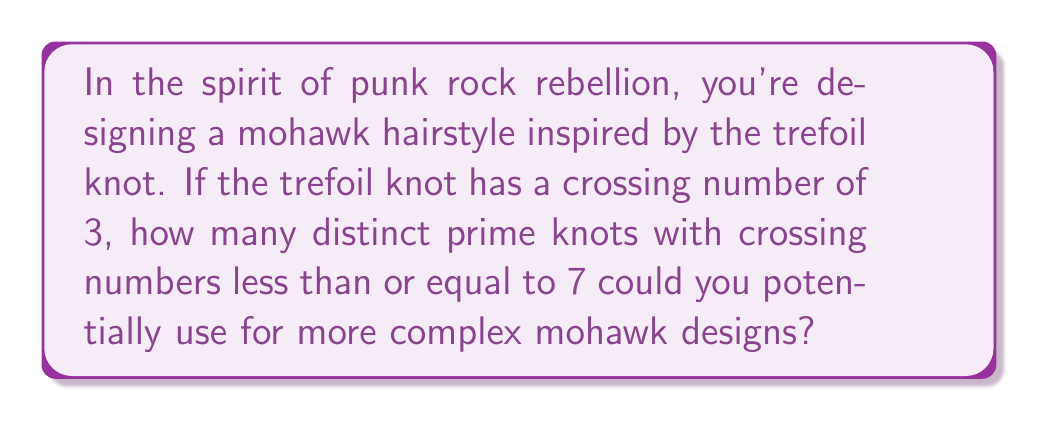Could you help me with this problem? To answer this question, we need to understand some basic concepts from knot theory and then count the number of prime knots with crossing numbers up to 7.

1. Knot theory basics:
   - A knot is a closed curve in three-dimensional space that doesn't intersect itself.
   - The crossing number of a knot is the minimum number of crossings in any diagram of the knot.
   - Prime knots are knots that cannot be decomposed into simpler knots.

2. Knots by crossing number:
   - Crossing number 0: The unknot (trivial knot)
   - Crossing number 3: Trefoil knot
   - Crossing number 4: Figure-eight knot
   - Crossing number 5: $5_1$ and $5_2$ knots
   - Crossing number 6: Three knots ($6_1$, $6_2$, $6_3$)
   - Crossing number 7: Seven knots ($7_1$ to $7_7$)

3. Counting prime knots:
   - Crossing number 0: 1 knot
   - Crossing number 3: 1 knot
   - Crossing number 4: 1 knot
   - Crossing number 5: 2 knots
   - Crossing number 6: 3 knots
   - Crossing number 7: 7 knots

4. Total count:
   $$1 + 1 + 1 + 2 + 3 + 7 = 15$$

Therefore, there are 15 distinct prime knots with crossing numbers less than or equal to 7 that could potentially be used for complex mohawk designs.
Answer: 15 distinct prime knots 